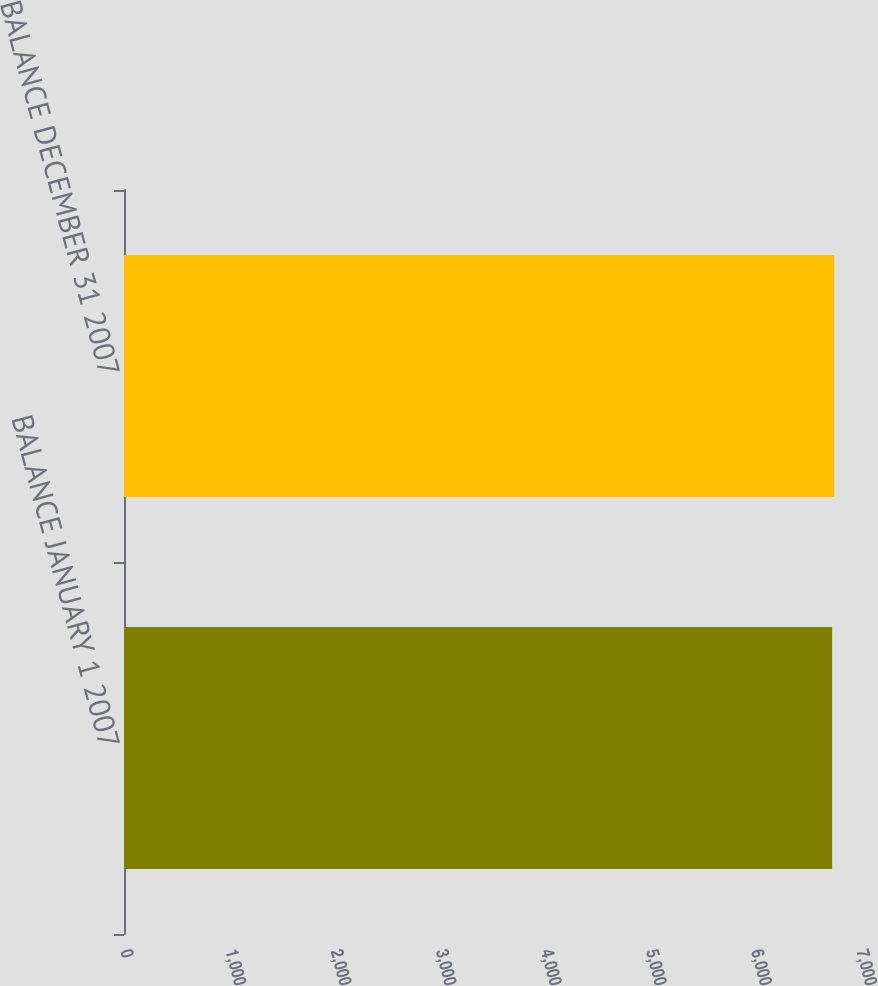<chart> <loc_0><loc_0><loc_500><loc_500><bar_chart><fcel>BALANCE JANUARY 1 2007<fcel>BALANCE DECEMBER 31 2007<nl><fcel>6735<fcel>6755<nl></chart> 